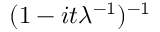Convert formula to latex. <formula><loc_0><loc_0><loc_500><loc_500>\, ( 1 - i t \lambda ^ { - 1 } ) ^ { - 1 }</formula> 